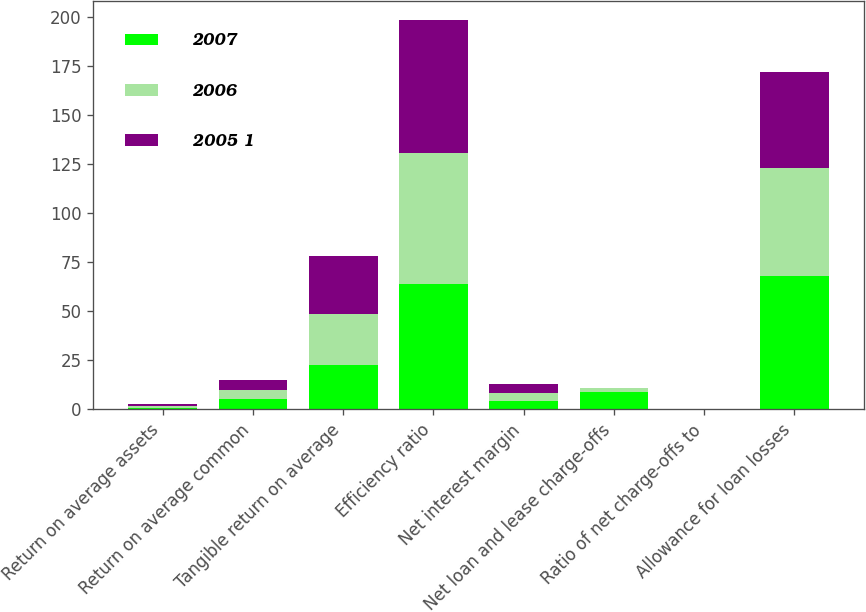<chart> <loc_0><loc_0><loc_500><loc_500><stacked_bar_chart><ecel><fcel>Return on average assets<fcel>Return on average common<fcel>Tangible return on average<fcel>Efficiency ratio<fcel>Net interest margin<fcel>Net loan and lease charge-offs<fcel>Ratio of net charge-offs to<fcel>Allowance for loan losses<nl><fcel>2007<fcel>0.91<fcel>5.1<fcel>22.46<fcel>63.83<fcel>4.13<fcel>9<fcel>0.13<fcel>68<nl><fcel>2006<fcel>0.93<fcel>4.87<fcel>26.25<fcel>66.79<fcel>4.36<fcel>1.9<fcel>0.03<fcel>55<nl><fcel>2005 1<fcel>0.97<fcel>4.97<fcel>29.72<fcel>68.03<fcel>4.44<fcel>0.2<fcel>0.04<fcel>49<nl></chart> 